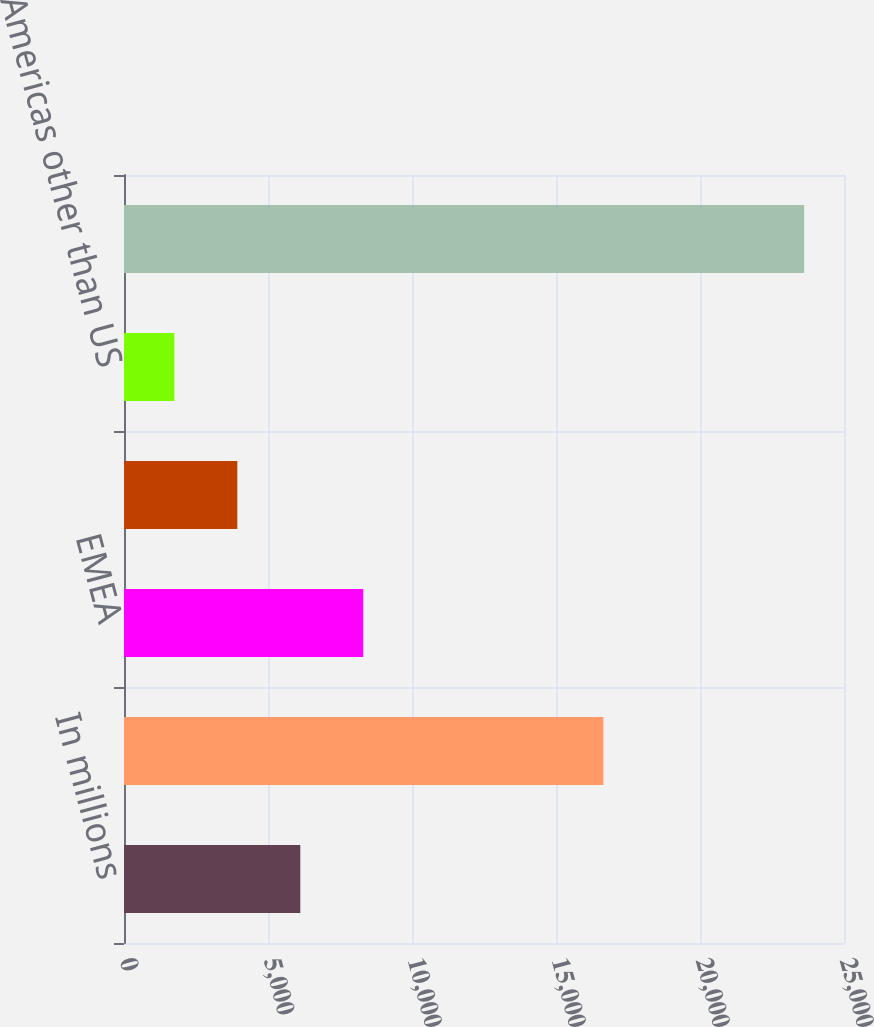Convert chart. <chart><loc_0><loc_0><loc_500><loc_500><bar_chart><fcel>In millions<fcel>United States (f)<fcel>EMEA<fcel>Pacific Rim and Asia<fcel>Americas other than US<fcel>Net Sales<nl><fcel>6121.8<fcel>16645<fcel>8308.7<fcel>3934.9<fcel>1748<fcel>23617<nl></chart> 